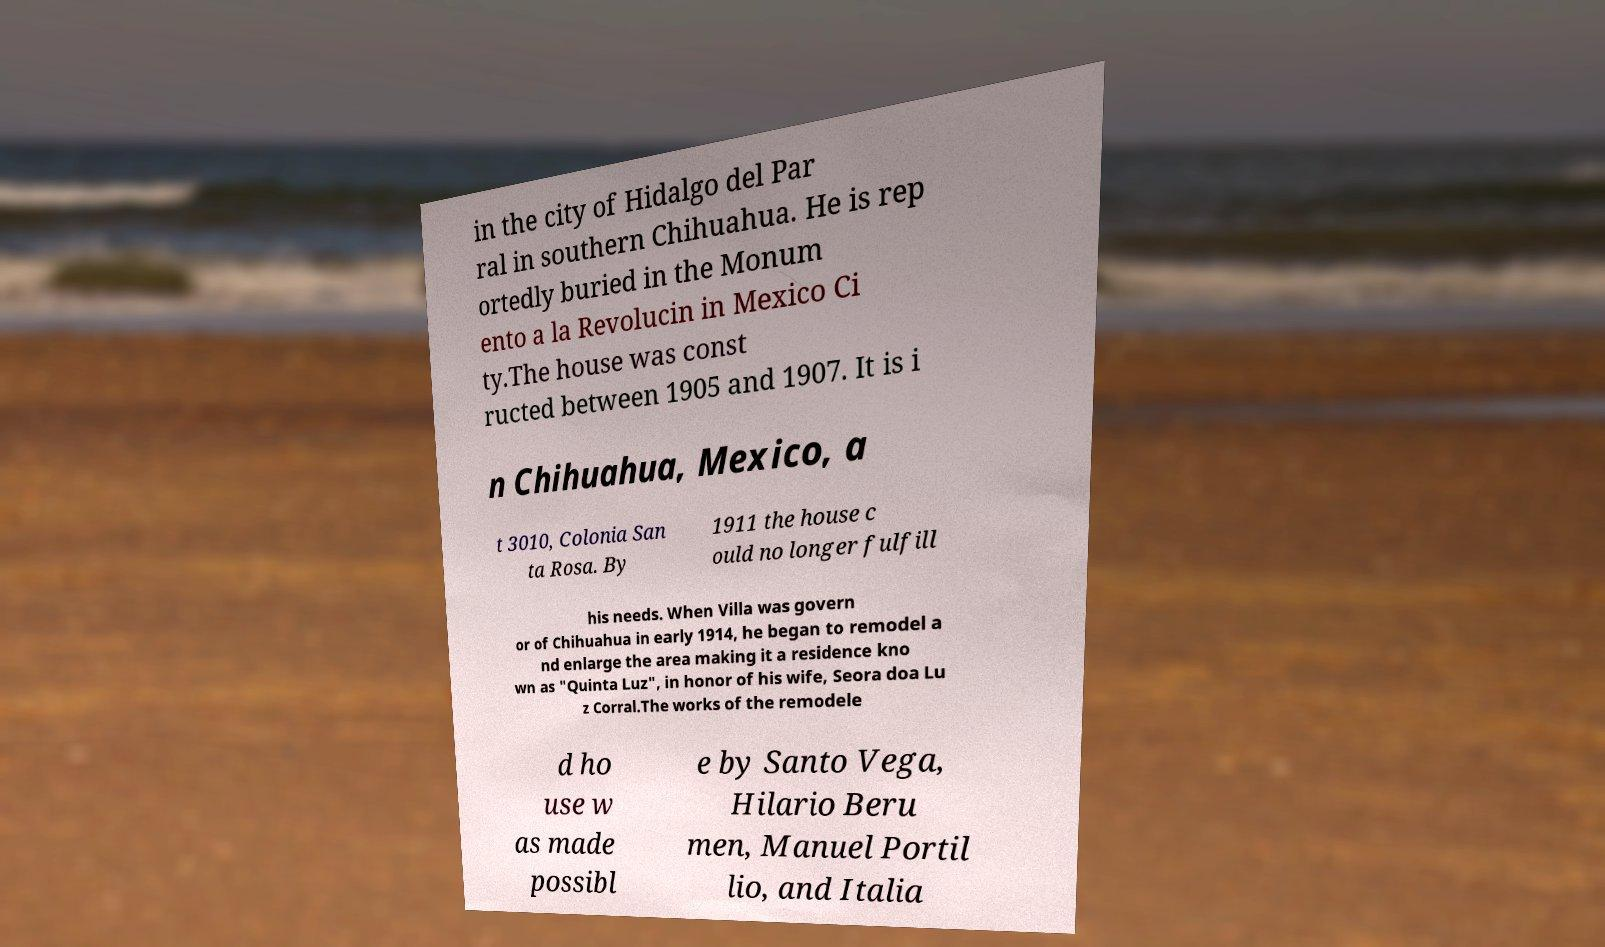Can you accurately transcribe the text from the provided image for me? in the city of Hidalgo del Par ral in southern Chihuahua. He is rep ortedly buried in the Monum ento a la Revolucin in Mexico Ci ty.The house was const ructed between 1905 and 1907. It is i n Chihuahua, Mexico, a t 3010, Colonia San ta Rosa. By 1911 the house c ould no longer fulfill his needs. When Villa was govern or of Chihuahua in early 1914, he began to remodel a nd enlarge the area making it a residence kno wn as "Quinta Luz", in honor of his wife, Seora doa Lu z Corral.The works of the remodele d ho use w as made possibl e by Santo Vega, Hilario Beru men, Manuel Portil lio, and Italia 